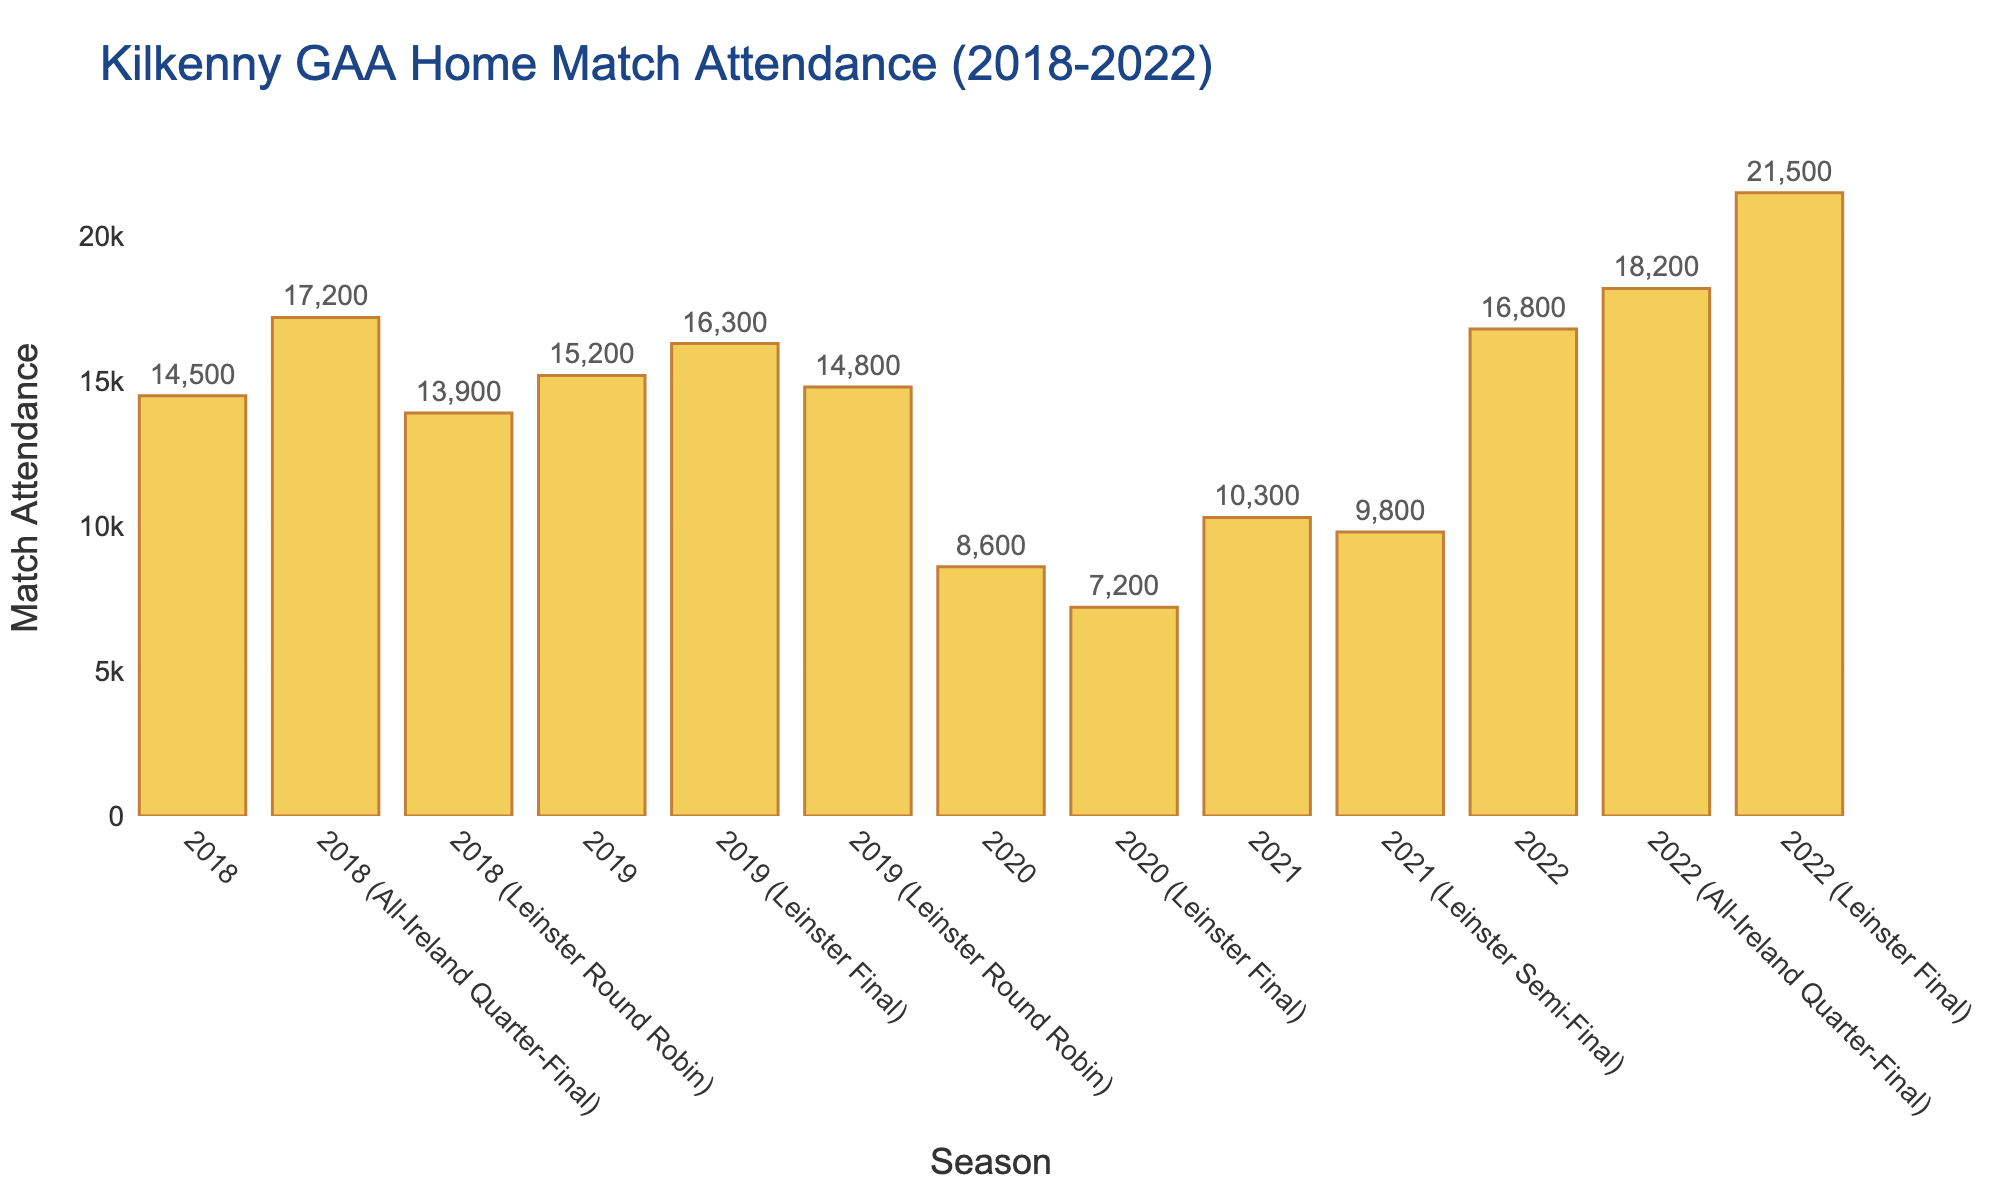Which season had the highest attendance for a Kilkenny home match? To determine the season with the highest attendance, inspect the bar chart for the tallest bar. The bar labeled "2022 (Leinster Final)" appears to be the tallest, indicating this match had the highest attendance.
Answer: 2022 (Leinster Final) What was the difference in attendance between the 2022 Leinster Final and the 2020 Leinster Final? Identify the attendance figures for both the 2022 Leinster Final (21,500) and the 2020 Leinster Final (7,200). Subtract the 2020 attendance from the 2022 attendance to find the difference: 21,500 - 7,200 = 14,300.
Answer: 14,300 How much did the attendance increase from the 2020 season to the 2021 season? Look at the attendance figures for the 2020 season (8,600) and the 2021 season (10,300). Calculate the increase by subtracting the 2020 attendance from the 2021 attendance: 10,300 - 8,600 = 1,700.
Answer: 1,700 Which year had a similar attendance for two different matches, and what were the matches? Review the attendance figures for each year and look for similar values. In 2019, the figures for the Leinster Round Robin (14,800) and the regular season (15,200) are very close.
Answer: 2019, Leinster Round Robin and 2019 regular season What is the average attendance across all listed 2022 matches? Add up the attendance figures for all 2022 matches: 16,800 + 18,200 + 21,500. Then divide by the number of matches (3): (16,800 + 18,200 + 21,500) / 3 = 18,833.33.
Answer: 18,833 How many matches had an attendance of over 15,000 spectators? Count the bars on the chart with attendance figures over 15,000. These are: 2019 regular season, 2019 Leinster Final, 2022 regular season, 2022 All-Ireland Quarter-Final, and 2022 Leinster Final. There are 5 such matches.
Answer: 5 Compare the attendance of the 2018 All-Ireland Quarter-Final to the 2019 Leinster Final. Which had higher attendance? Check the attendance figures for each match: 2018 All-Ireland Quarter-Final (17,200) and 2019 Leinster Final (16,300). 17,200 is greater than 16,300.
Answer: 2018 All-Ireland Quarter-Final Did the attendance generally increase or decrease from 2018 to 2022 for regular matches? Compare the attendance figures for 2018 (14,500), 2019 (15,200), 2020 (8,600), 2021 (10,300), and 2022 (16,800). Notice that the numbers fluctuate but generally show an increasing trend from 2020 onward.
Answer: Increase 